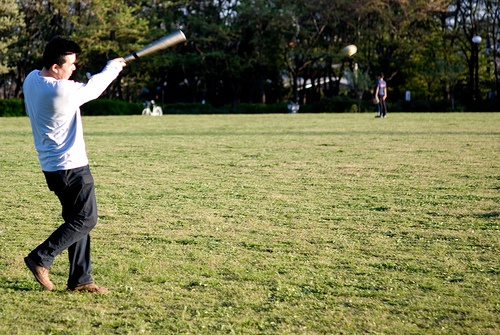Describe the objects in this image and their specific colors. I can see people in olive, black, white, and gray tones, baseball bat in olive, black, tan, darkgray, and gray tones, people in olive, black, gray, lightpink, and darkgray tones, people in olive, white, darkgray, black, and teal tones, and sports ball in olive, beige, tan, darkgreen, and gray tones in this image. 